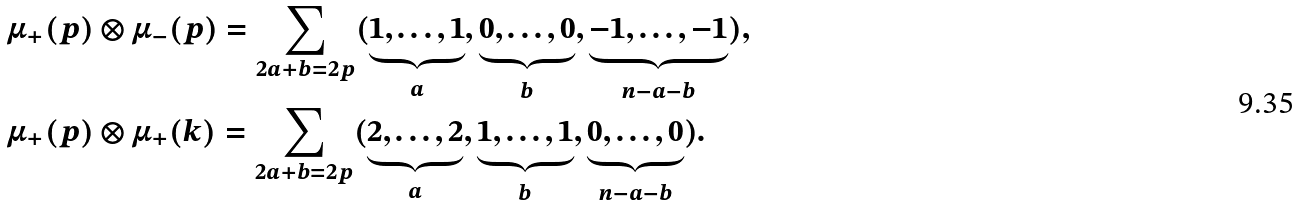<formula> <loc_0><loc_0><loc_500><loc_500>& \mu _ { + } ( p ) \otimes \mu _ { - } ( p ) = \sum _ { 2 a + b = 2 p } ( \underbrace { 1 , \dots , 1 } _ { a } , \underbrace { 0 , \dots , 0 } _ { b } , \underbrace { - 1 , \dots , - 1 } _ { n - a - b } ) , \\ & \mu _ { + } ( p ) \otimes \mu _ { + } ( k ) = \sum _ { 2 a + b = 2 p } ( \underbrace { 2 , \dots , 2 } _ { a } , \underbrace { 1 , \dots , 1 } _ { b } , \underbrace { 0 , \dots , 0 } _ { n - a - b } ) .</formula> 